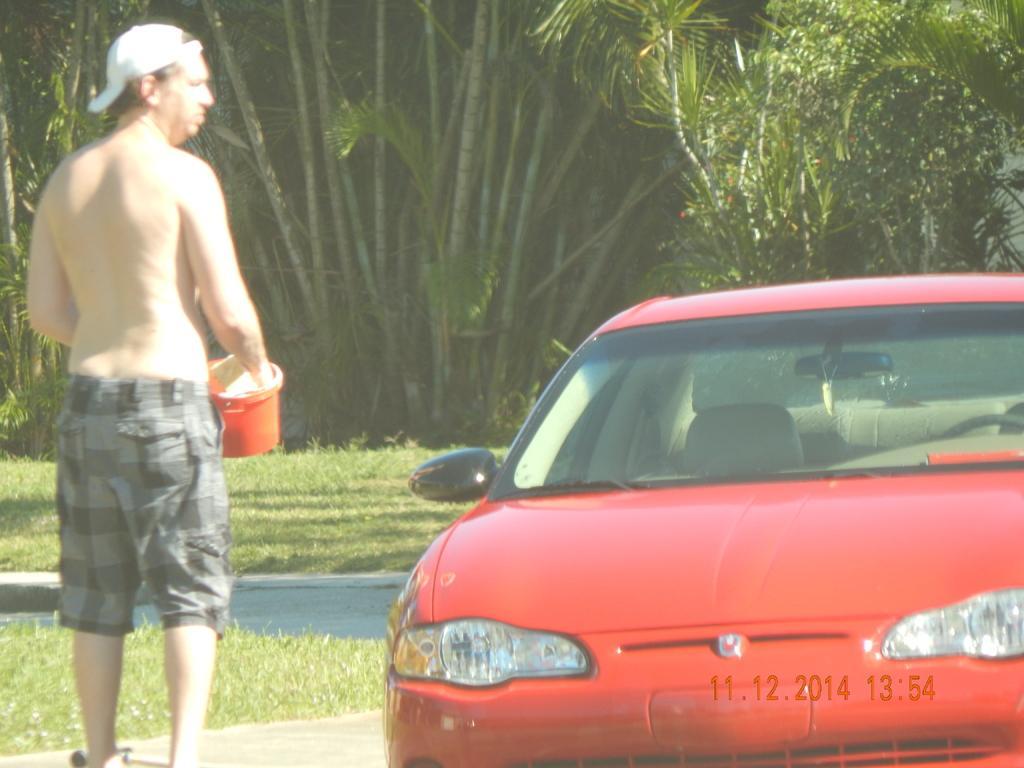Can you describe this image briefly? In this picture I can see there is a man standing and he is holding a bucket, wearing a cap and a trouser. There is a red color car at the right side. There are grass and trees in the backdrop. 